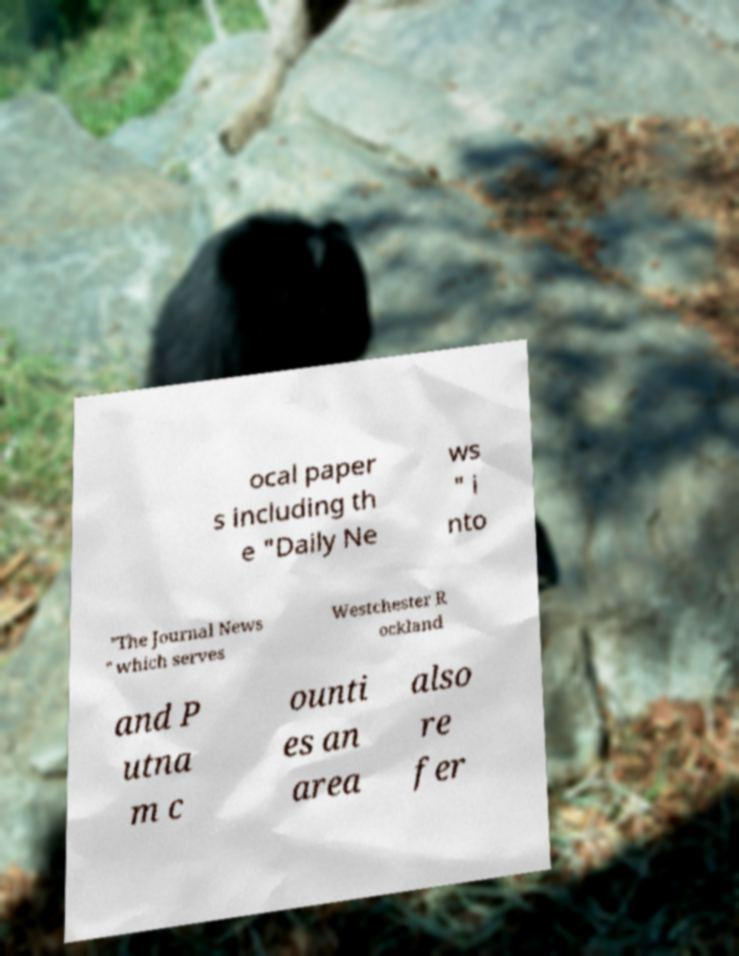Can you read and provide the text displayed in the image?This photo seems to have some interesting text. Can you extract and type it out for me? ocal paper s including th e "Daily Ne ws " i nto "The Journal News " which serves Westchester R ockland and P utna m c ounti es an area also re fer 